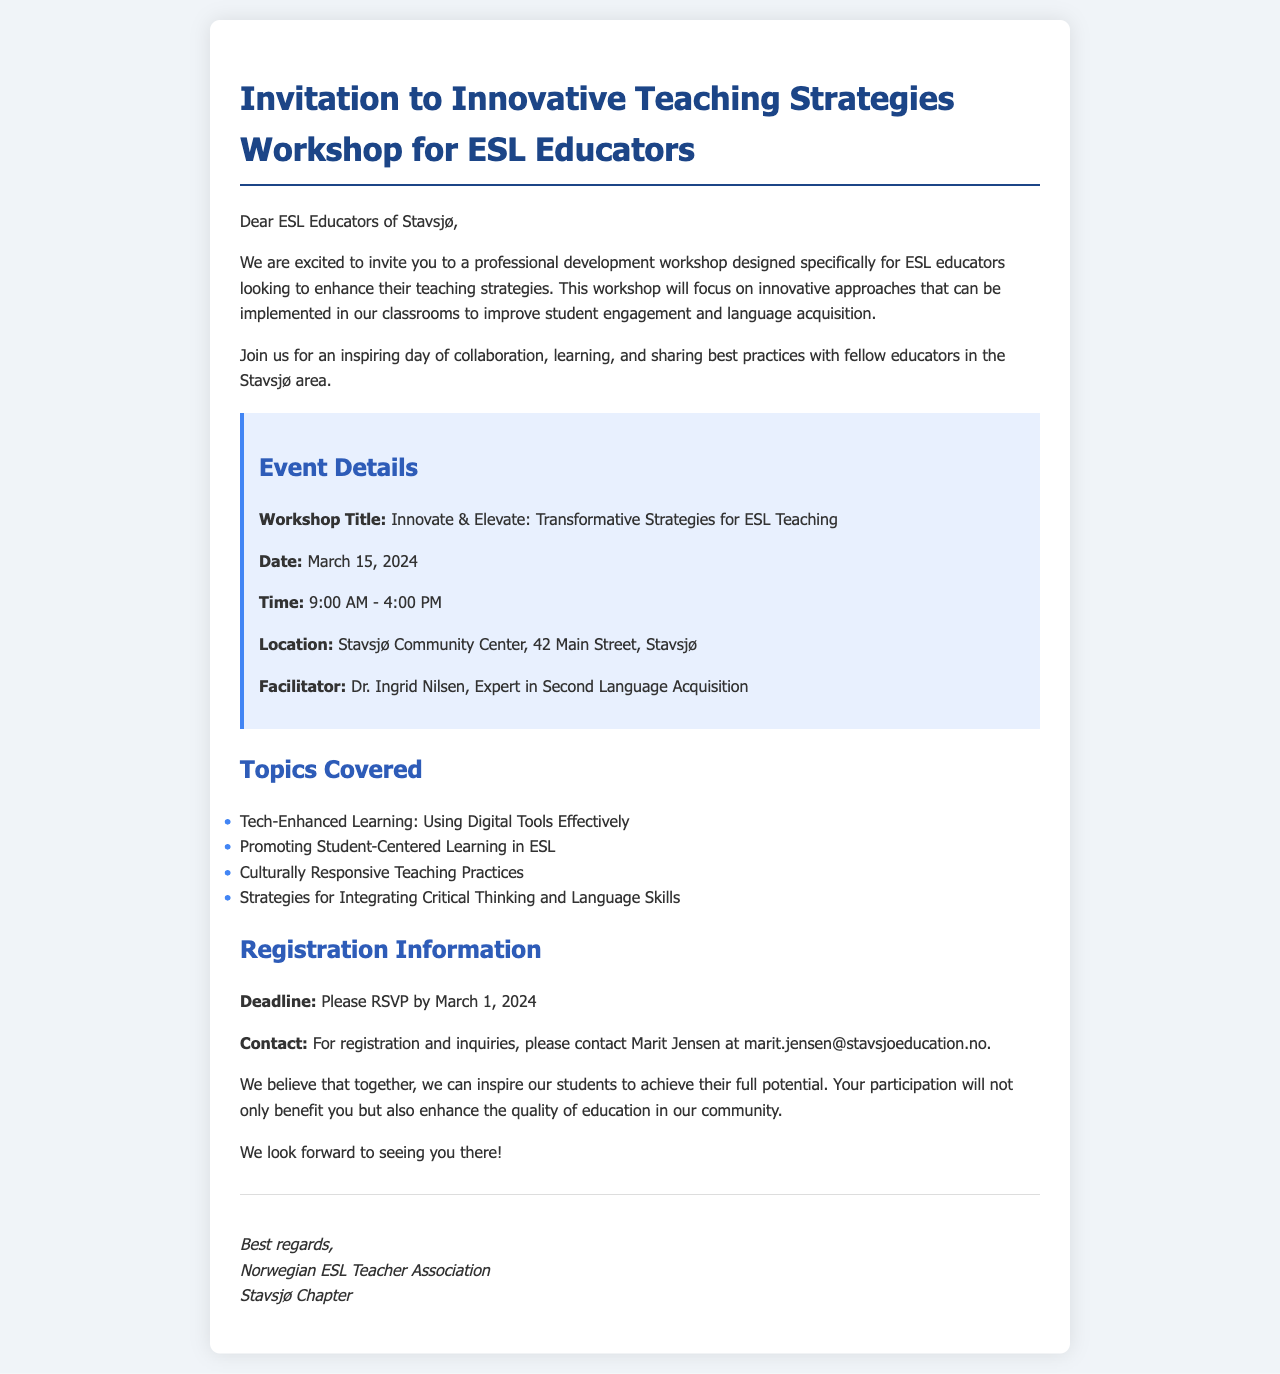what is the workshop title? The workshop title is clearly stated in the event details section, which is "Innovate & Elevate: Transformative Strategies for ESL Teaching."
Answer: Innovate & Elevate: Transformative Strategies for ESL Teaching when is the registration deadline? The registration deadline is mentioned explicitly in the registration information, which states to RSVP by March 1, 2024.
Answer: March 1, 2024 who is the facilitator of the workshop? The name of the facilitator is provided in the event details section, identified as Dr. Ingrid Nilsen.
Answer: Dr. Ingrid Nilsen where is the workshop located? The location of the workshop is detailed in the event section, specifying "Stavsjø Community Center, 42 Main Street, Stavsjø."
Answer: Stavsjø Community Center, 42 Main Street, Stavsjø what time does the workshop start? The start time for the workshop is listed in the event details, which is 9:00 AM.
Answer: 9:00 AM what topic focuses on digital tools? One of the topics covered specifically mentions using digital tools, which is "Tech-Enhanced Learning: Using Digital Tools Effectively."
Answer: Tech-Enhanced Learning: Using Digital Tools Effectively how long is the duration of the workshop? The workshop's duration is defined by the stated starting and ending times, which span from 9:00 AM to 4:00 PM, equating to 7 hours.
Answer: 7 hours who should be contacted for registration inquiries? The document specifies who to contact for registration inquiries as Marit Jensen.
Answer: Marit Jensen 